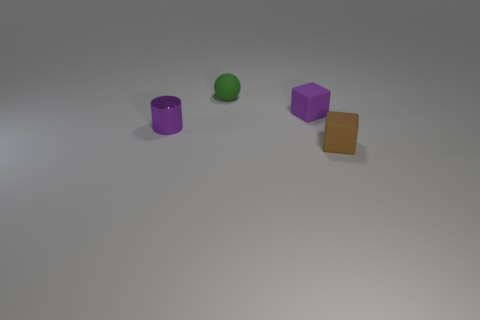There is another matte object that is the same shape as the tiny purple matte thing; what color is it?
Your answer should be compact. Brown. What is the purple thing that is on the left side of the purple matte object behind the metal thing that is in front of the rubber sphere made of?
Your response must be concise. Metal. Do the tiny purple rubber object and the brown thing have the same shape?
Your answer should be compact. Yes. How many metal things are either green objects or small green cubes?
Keep it short and to the point. 0. What number of blue rubber cylinders are there?
Your response must be concise. 0. There is a matte ball that is the same size as the purple metallic object; what is its color?
Keep it short and to the point. Green. Do the purple cube and the brown matte thing have the same size?
Your answer should be very brief. Yes. There is a brown rubber block; is it the same size as the rubber object that is behind the small purple block?
Your answer should be compact. Yes. What color is the tiny thing that is both to the right of the tiny green object and behind the brown cube?
Make the answer very short. Purple. Is the number of brown matte things behind the purple rubber object greater than the number of shiny objects behind the tiny green rubber ball?
Make the answer very short. No. 